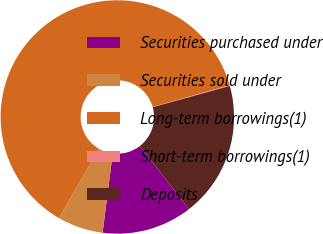<chart> <loc_0><loc_0><loc_500><loc_500><pie_chart><fcel>Securities purchased under<fcel>Securities sold under<fcel>Long-term borrowings(1)<fcel>Short-term borrowings(1)<fcel>Deposits<nl><fcel>12.54%<fcel>6.33%<fcel>62.25%<fcel>0.12%<fcel>18.76%<nl></chart> 